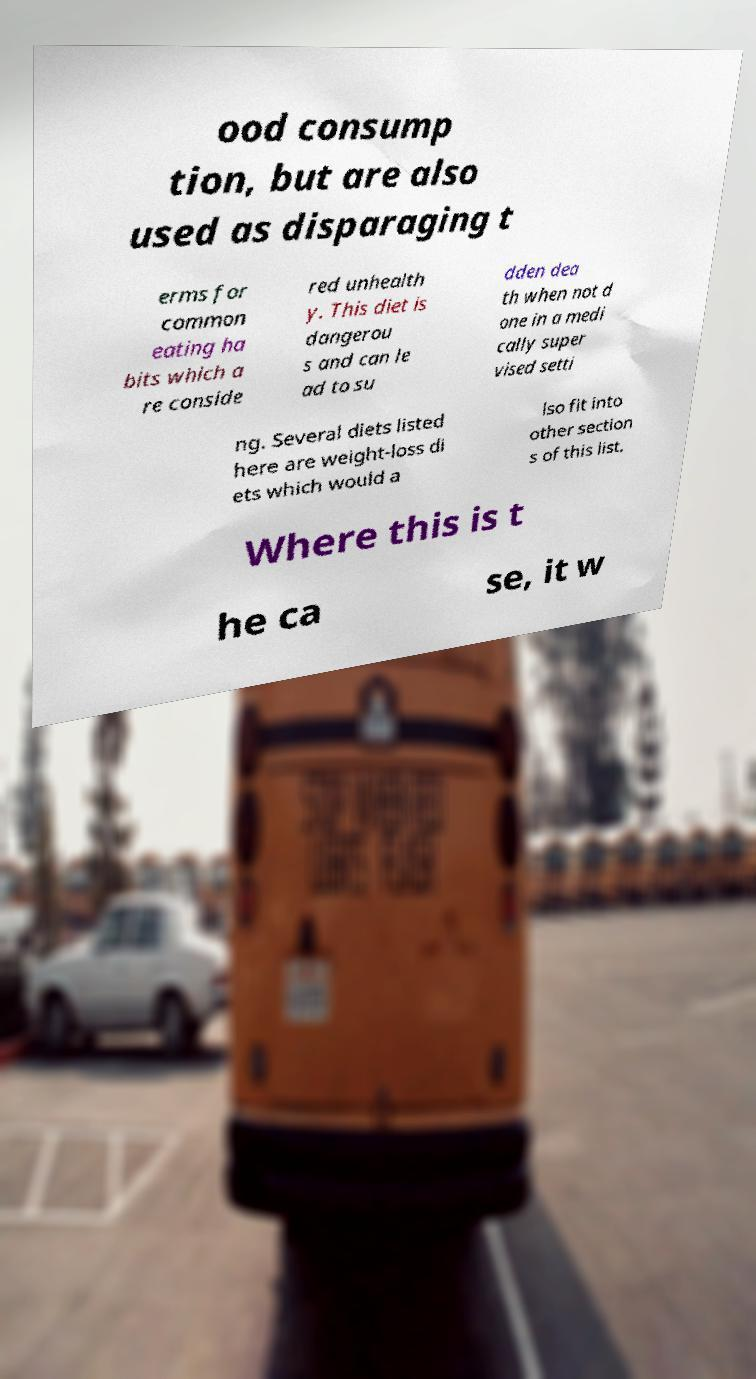Please identify and transcribe the text found in this image. ood consump tion, but are also used as disparaging t erms for common eating ha bits which a re conside red unhealth y. This diet is dangerou s and can le ad to su dden dea th when not d one in a medi cally super vised setti ng. Several diets listed here are weight-loss di ets which would a lso fit into other section s of this list. Where this is t he ca se, it w 